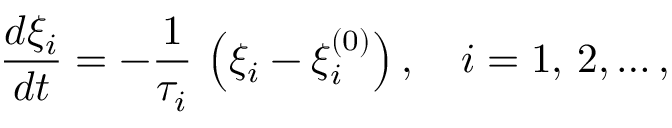<formula> <loc_0><loc_0><loc_500><loc_500>{ \frac { d \xi _ { i } } { d t } } = - { \frac { 1 } { \tau _ { i } } } \, \left ( \xi _ { i } - \xi _ { i } ^ { ( 0 ) } \right ) , \quad i = 1 , \, 2 , \dots ,</formula> 